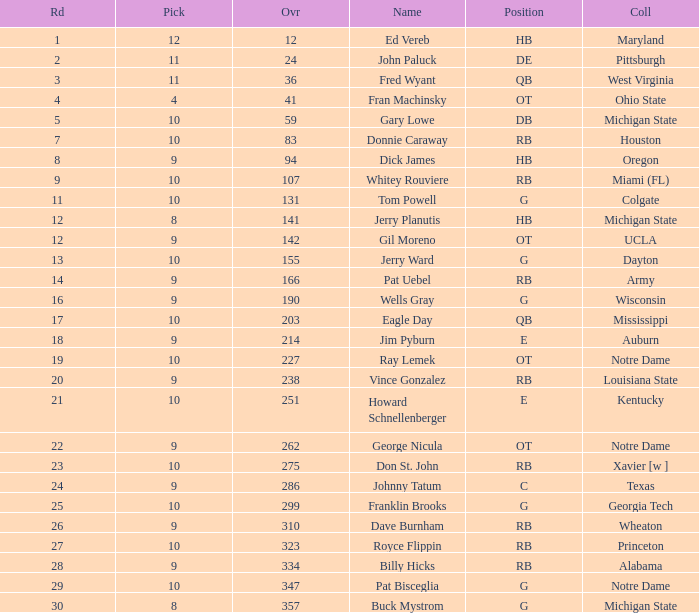What is the total number of overall picks that were after pick 9 and went to Auburn College? 0.0. 